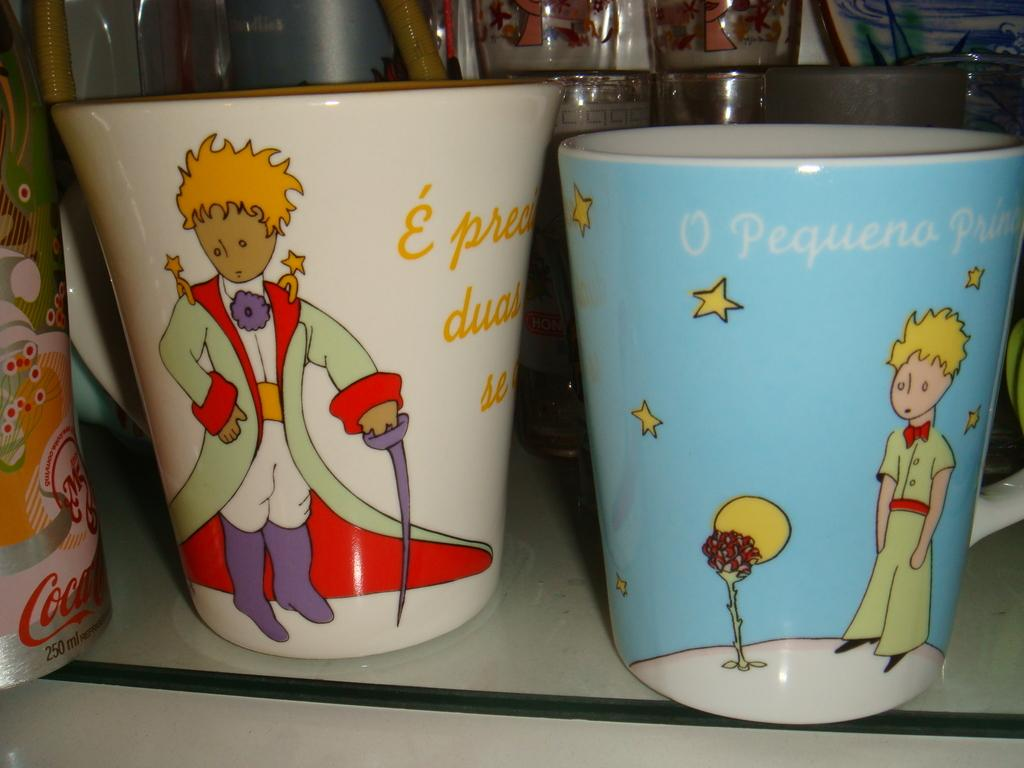What type of containers are visible in the image? There are glass tumblers in the image. Where are the glass tumblers located? The glass tumblers are on the floor. How many girls are holding the glass tumblers in the image? There are no girls present in the image; it only shows glass tumblers on the floor. What type of clouds can be seen in the image? There are no clouds visible in the image, as it only features glass tumblers on the floor. 